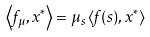<formula> <loc_0><loc_0><loc_500><loc_500>\left \langle f _ { \mu } , x ^ { \ast } \right \rangle = \mu _ { s } \left \langle f ( s ) , x ^ { \ast } \right \rangle</formula> 